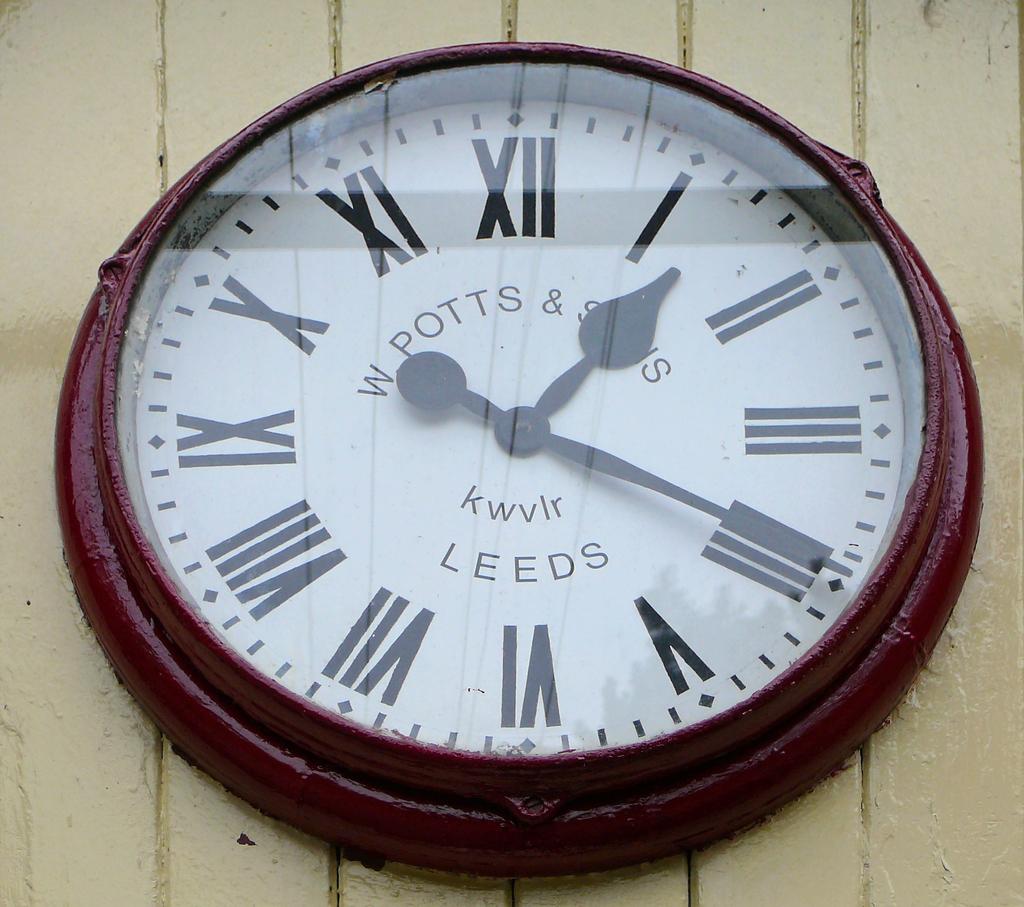What time is it?
Provide a succinct answer. 1:20. What city is listed below?
Provide a short and direct response. Leeds. 